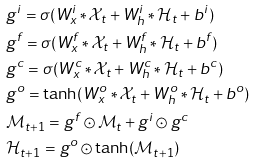Convert formula to latex. <formula><loc_0><loc_0><loc_500><loc_500>& g ^ { i } = \sigma ( W ^ { i } _ { x } * \mathcal { X } _ { t } + W ^ { i } _ { h } * \mathcal { H } _ { t } + b ^ { i } ) \\ & g ^ { f } = \sigma ( W ^ { f } _ { x } * \mathcal { X } _ { t } + W ^ { f } _ { h } * \mathcal { H } _ { t } + b ^ { f } ) \\ & g ^ { c } = \sigma ( W ^ { c } _ { x } * \mathcal { X } _ { t } + W ^ { c } _ { h } * \mathcal { H } _ { t } + b ^ { c } ) \\ & g ^ { o } = \tanh ( W ^ { o } _ { x } * \mathcal { X } _ { t } + W ^ { o } _ { h } * \mathcal { H } _ { t } + b ^ { o } ) \\ & \mathcal { M } _ { t + 1 } = g ^ { f } \odot \mathcal { M } _ { t } + g ^ { i } \odot g ^ { c } \\ & \mathcal { H } _ { t + 1 } = g ^ { o } \odot \tanh ( \mathcal { M } _ { t + 1 } )</formula> 